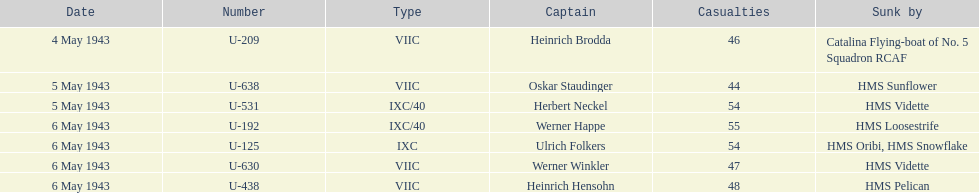What was the only captain submerged by hms pelican? Heinrich Hensohn. 